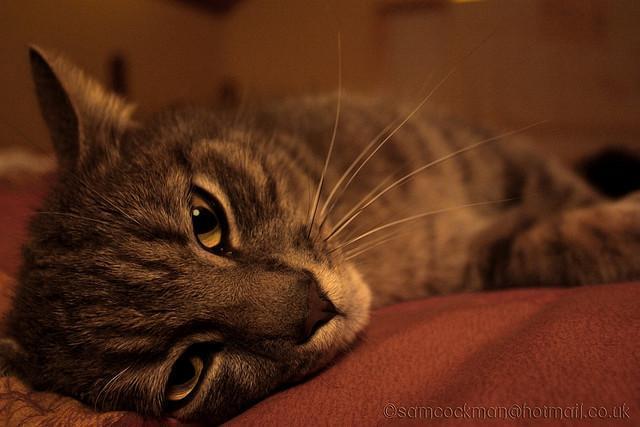How many whiskers are on the left side of the cat's nose?
Give a very brief answer. 8. How many whiskers are shown in the picture?
Give a very brief answer. 8. 